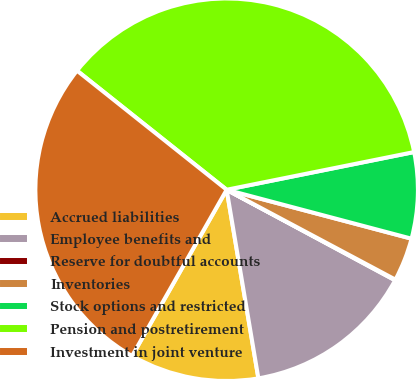Convert chart. <chart><loc_0><loc_0><loc_500><loc_500><pie_chart><fcel>Accrued liabilities<fcel>Employee benefits and<fcel>Reserve for doubtful accounts<fcel>Inventories<fcel>Stock options and restricted<fcel>Pension and postretirement<fcel>Investment in joint venture<nl><fcel>10.89%<fcel>14.5%<fcel>0.06%<fcel>3.67%<fcel>7.28%<fcel>36.15%<fcel>27.47%<nl></chart> 